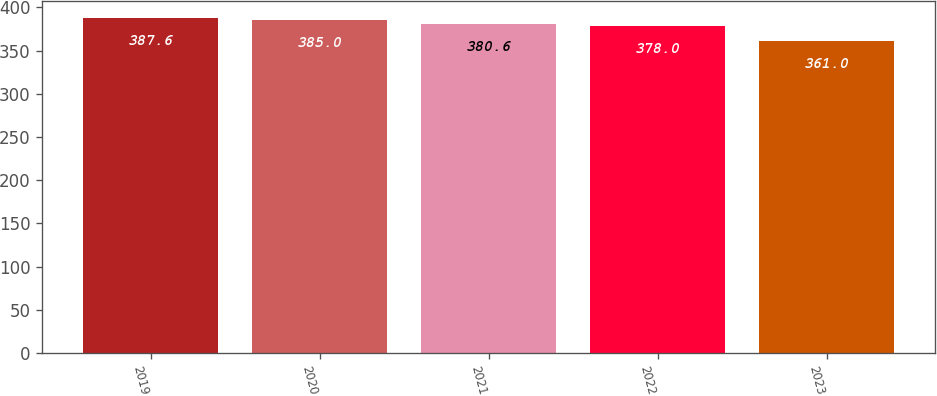<chart> <loc_0><loc_0><loc_500><loc_500><bar_chart><fcel>2019<fcel>2020<fcel>2021<fcel>2022<fcel>2023<nl><fcel>387.6<fcel>385<fcel>380.6<fcel>378<fcel>361<nl></chart> 